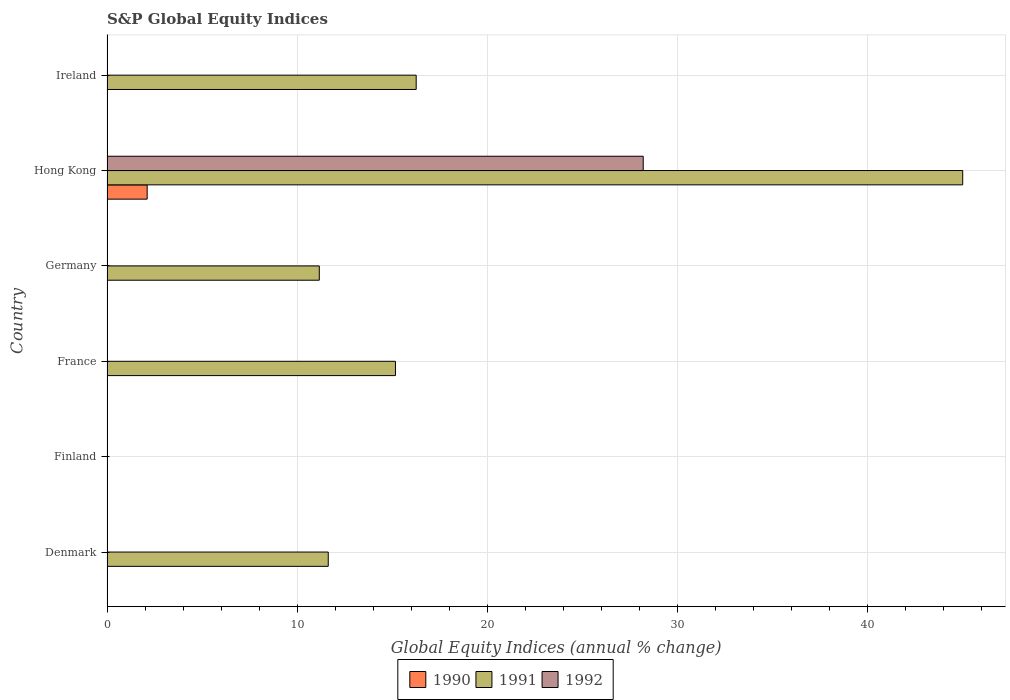Are the number of bars per tick equal to the number of legend labels?
Make the answer very short. No. Are the number of bars on each tick of the Y-axis equal?
Your response must be concise. No. What is the label of the 6th group of bars from the top?
Make the answer very short. Denmark. What is the global equity indices in 1991 in France?
Your answer should be compact. 15.17. Across all countries, what is the maximum global equity indices in 1991?
Offer a very short reply. 44.99. Across all countries, what is the minimum global equity indices in 1992?
Provide a succinct answer. 0. In which country was the global equity indices in 1991 maximum?
Your answer should be compact. Hong Kong. What is the total global equity indices in 1992 in the graph?
Your answer should be very brief. 28.19. What is the difference between the global equity indices in 1991 in France and that in Germany?
Ensure brevity in your answer.  4. What is the difference between the global equity indices in 1992 in Hong Kong and the global equity indices in 1991 in Ireland?
Your answer should be compact. 11.94. What is the average global equity indices in 1992 per country?
Give a very brief answer. 4.7. In how many countries, is the global equity indices in 1990 greater than 8 %?
Your answer should be compact. 0. What is the ratio of the global equity indices in 1991 in Hong Kong to that in Ireland?
Your answer should be very brief. 2.77. What is the difference between the highest and the second highest global equity indices in 1991?
Give a very brief answer. 28.74. What is the difference between the highest and the lowest global equity indices in 1992?
Your response must be concise. 28.19. In how many countries, is the global equity indices in 1992 greater than the average global equity indices in 1992 taken over all countries?
Offer a very short reply. 1. Is it the case that in every country, the sum of the global equity indices in 1990 and global equity indices in 1992 is greater than the global equity indices in 1991?
Provide a short and direct response. No. Are the values on the major ticks of X-axis written in scientific E-notation?
Make the answer very short. No. How many legend labels are there?
Make the answer very short. 3. How are the legend labels stacked?
Provide a short and direct response. Horizontal. What is the title of the graph?
Offer a very short reply. S&P Global Equity Indices. What is the label or title of the X-axis?
Offer a terse response. Global Equity Indices (annual % change). What is the Global Equity Indices (annual % change) in 1991 in Denmark?
Ensure brevity in your answer.  11.63. What is the Global Equity Indices (annual % change) of 1990 in Finland?
Offer a very short reply. 0. What is the Global Equity Indices (annual % change) of 1991 in Finland?
Offer a terse response. 0. What is the Global Equity Indices (annual % change) of 1992 in Finland?
Offer a terse response. 0. What is the Global Equity Indices (annual % change) of 1990 in France?
Give a very brief answer. 0. What is the Global Equity Indices (annual % change) of 1991 in France?
Give a very brief answer. 15.17. What is the Global Equity Indices (annual % change) in 1991 in Germany?
Offer a terse response. 11.16. What is the Global Equity Indices (annual % change) in 1990 in Hong Kong?
Give a very brief answer. 2.11. What is the Global Equity Indices (annual % change) of 1991 in Hong Kong?
Offer a terse response. 44.99. What is the Global Equity Indices (annual % change) in 1992 in Hong Kong?
Offer a very short reply. 28.19. What is the Global Equity Indices (annual % change) in 1991 in Ireland?
Provide a short and direct response. 16.26. Across all countries, what is the maximum Global Equity Indices (annual % change) in 1990?
Ensure brevity in your answer.  2.11. Across all countries, what is the maximum Global Equity Indices (annual % change) in 1991?
Offer a very short reply. 44.99. Across all countries, what is the maximum Global Equity Indices (annual % change) of 1992?
Your response must be concise. 28.19. Across all countries, what is the minimum Global Equity Indices (annual % change) of 1990?
Your response must be concise. 0. Across all countries, what is the minimum Global Equity Indices (annual % change) in 1991?
Give a very brief answer. 0. What is the total Global Equity Indices (annual % change) in 1990 in the graph?
Ensure brevity in your answer.  2.11. What is the total Global Equity Indices (annual % change) of 1991 in the graph?
Provide a short and direct response. 99.21. What is the total Global Equity Indices (annual % change) of 1992 in the graph?
Provide a succinct answer. 28.19. What is the difference between the Global Equity Indices (annual % change) in 1991 in Denmark and that in France?
Give a very brief answer. -3.53. What is the difference between the Global Equity Indices (annual % change) in 1991 in Denmark and that in Germany?
Make the answer very short. 0.47. What is the difference between the Global Equity Indices (annual % change) in 1991 in Denmark and that in Hong Kong?
Keep it short and to the point. -33.36. What is the difference between the Global Equity Indices (annual % change) of 1991 in Denmark and that in Ireland?
Your answer should be very brief. -4.62. What is the difference between the Global Equity Indices (annual % change) of 1991 in France and that in Germany?
Make the answer very short. 4. What is the difference between the Global Equity Indices (annual % change) of 1991 in France and that in Hong Kong?
Offer a very short reply. -29.83. What is the difference between the Global Equity Indices (annual % change) in 1991 in France and that in Ireland?
Offer a very short reply. -1.09. What is the difference between the Global Equity Indices (annual % change) in 1991 in Germany and that in Hong Kong?
Your response must be concise. -33.83. What is the difference between the Global Equity Indices (annual % change) of 1991 in Germany and that in Ireland?
Your response must be concise. -5.09. What is the difference between the Global Equity Indices (annual % change) of 1991 in Hong Kong and that in Ireland?
Your answer should be compact. 28.74. What is the difference between the Global Equity Indices (annual % change) of 1991 in Denmark and the Global Equity Indices (annual % change) of 1992 in Hong Kong?
Provide a succinct answer. -16.56. What is the difference between the Global Equity Indices (annual % change) in 1991 in France and the Global Equity Indices (annual % change) in 1992 in Hong Kong?
Ensure brevity in your answer.  -13.03. What is the difference between the Global Equity Indices (annual % change) in 1991 in Germany and the Global Equity Indices (annual % change) in 1992 in Hong Kong?
Offer a very short reply. -17.03. What is the difference between the Global Equity Indices (annual % change) of 1990 in Hong Kong and the Global Equity Indices (annual % change) of 1991 in Ireland?
Offer a very short reply. -14.14. What is the average Global Equity Indices (annual % change) of 1990 per country?
Give a very brief answer. 0.35. What is the average Global Equity Indices (annual % change) of 1991 per country?
Provide a short and direct response. 16.54. What is the average Global Equity Indices (annual % change) of 1992 per country?
Give a very brief answer. 4.7. What is the difference between the Global Equity Indices (annual % change) of 1990 and Global Equity Indices (annual % change) of 1991 in Hong Kong?
Ensure brevity in your answer.  -42.88. What is the difference between the Global Equity Indices (annual % change) in 1990 and Global Equity Indices (annual % change) in 1992 in Hong Kong?
Your answer should be compact. -26.08. What is the difference between the Global Equity Indices (annual % change) in 1991 and Global Equity Indices (annual % change) in 1992 in Hong Kong?
Keep it short and to the point. 16.8. What is the ratio of the Global Equity Indices (annual % change) in 1991 in Denmark to that in France?
Ensure brevity in your answer.  0.77. What is the ratio of the Global Equity Indices (annual % change) of 1991 in Denmark to that in Germany?
Provide a succinct answer. 1.04. What is the ratio of the Global Equity Indices (annual % change) in 1991 in Denmark to that in Hong Kong?
Your answer should be very brief. 0.26. What is the ratio of the Global Equity Indices (annual % change) of 1991 in Denmark to that in Ireland?
Your response must be concise. 0.72. What is the ratio of the Global Equity Indices (annual % change) in 1991 in France to that in Germany?
Offer a terse response. 1.36. What is the ratio of the Global Equity Indices (annual % change) of 1991 in France to that in Hong Kong?
Provide a short and direct response. 0.34. What is the ratio of the Global Equity Indices (annual % change) in 1991 in France to that in Ireland?
Offer a very short reply. 0.93. What is the ratio of the Global Equity Indices (annual % change) of 1991 in Germany to that in Hong Kong?
Ensure brevity in your answer.  0.25. What is the ratio of the Global Equity Indices (annual % change) of 1991 in Germany to that in Ireland?
Ensure brevity in your answer.  0.69. What is the ratio of the Global Equity Indices (annual % change) of 1991 in Hong Kong to that in Ireland?
Provide a short and direct response. 2.77. What is the difference between the highest and the second highest Global Equity Indices (annual % change) in 1991?
Offer a terse response. 28.74. What is the difference between the highest and the lowest Global Equity Indices (annual % change) in 1990?
Ensure brevity in your answer.  2.11. What is the difference between the highest and the lowest Global Equity Indices (annual % change) in 1991?
Ensure brevity in your answer.  44.99. What is the difference between the highest and the lowest Global Equity Indices (annual % change) of 1992?
Keep it short and to the point. 28.19. 